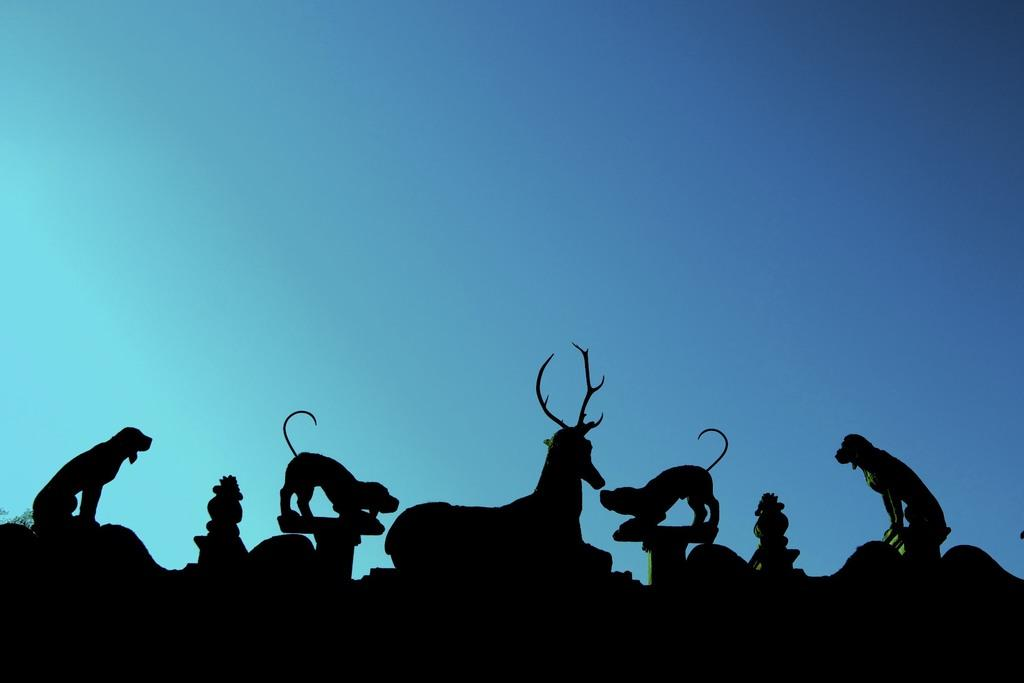What types of animals can be seen in the image? There are different shaped animals in the image. Where are the animals located in the image? The animals are on the surface in the image. What can be seen in the background of the image? The sky is visible in the background of the image. How would you describe the sky in the image? The sky appears to be clear in the image. What color is the egg on the neck of the animal in the image? There is no egg or neck present in the image; it features different shaped animals on a surface with a clear sky in the background. 